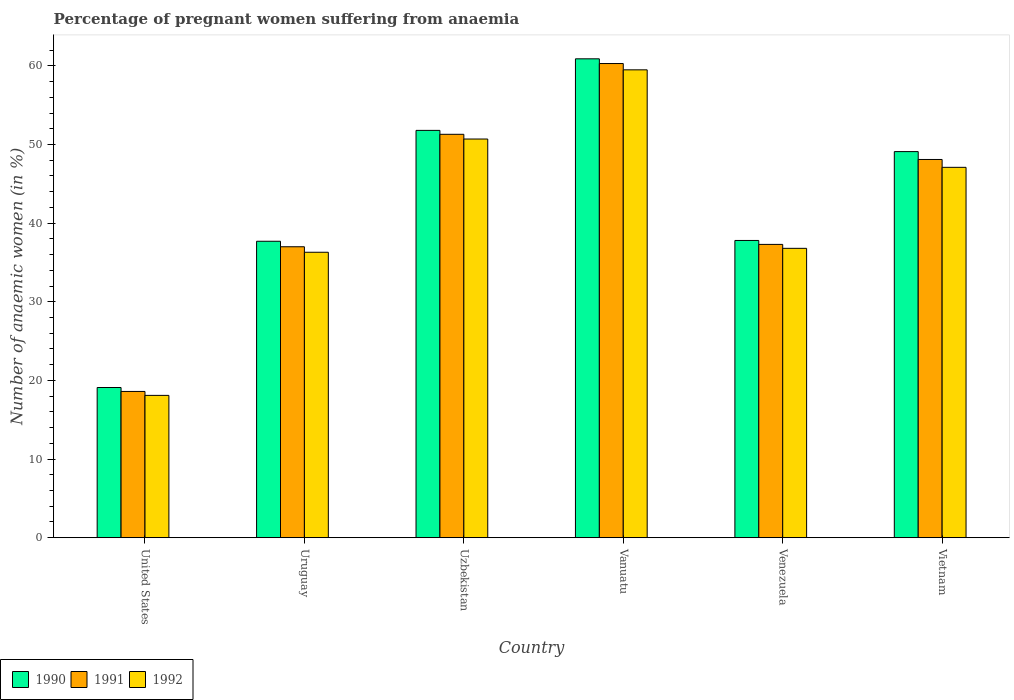How many bars are there on the 2nd tick from the right?
Provide a short and direct response. 3. What is the label of the 5th group of bars from the left?
Keep it short and to the point. Venezuela. What is the number of anaemic women in 1990 in Uzbekistan?
Offer a terse response. 51.8. Across all countries, what is the maximum number of anaemic women in 1990?
Provide a short and direct response. 60.9. Across all countries, what is the minimum number of anaemic women in 1991?
Give a very brief answer. 18.6. In which country was the number of anaemic women in 1992 maximum?
Your answer should be compact. Vanuatu. In which country was the number of anaemic women in 1990 minimum?
Give a very brief answer. United States. What is the total number of anaemic women in 1990 in the graph?
Give a very brief answer. 256.4. What is the difference between the number of anaemic women in 1992 in Vanuatu and that in Vietnam?
Provide a short and direct response. 12.4. What is the difference between the number of anaemic women in 1991 in United States and the number of anaemic women in 1992 in Uzbekistan?
Your answer should be very brief. -32.1. What is the average number of anaemic women in 1991 per country?
Offer a very short reply. 42.1. What is the difference between the number of anaemic women of/in 1990 and number of anaemic women of/in 1992 in Vanuatu?
Give a very brief answer. 1.4. What is the ratio of the number of anaemic women in 1990 in Vanuatu to that in Vietnam?
Ensure brevity in your answer.  1.24. What is the difference between the highest and the second highest number of anaemic women in 1990?
Your answer should be very brief. -2.7. What is the difference between the highest and the lowest number of anaemic women in 1990?
Make the answer very short. 41.8. What does the 1st bar from the left in Uruguay represents?
Your answer should be compact. 1990. Are all the bars in the graph horizontal?
Your answer should be very brief. No. How many countries are there in the graph?
Provide a succinct answer. 6. Are the values on the major ticks of Y-axis written in scientific E-notation?
Your response must be concise. No. Does the graph contain grids?
Give a very brief answer. No. Where does the legend appear in the graph?
Your answer should be compact. Bottom left. How many legend labels are there?
Provide a short and direct response. 3. How are the legend labels stacked?
Your answer should be very brief. Horizontal. What is the title of the graph?
Your answer should be very brief. Percentage of pregnant women suffering from anaemia. What is the label or title of the Y-axis?
Your answer should be compact. Number of anaemic women (in %). What is the Number of anaemic women (in %) in 1990 in Uruguay?
Provide a succinct answer. 37.7. What is the Number of anaemic women (in %) in 1992 in Uruguay?
Provide a succinct answer. 36.3. What is the Number of anaemic women (in %) of 1990 in Uzbekistan?
Ensure brevity in your answer.  51.8. What is the Number of anaemic women (in %) of 1991 in Uzbekistan?
Your answer should be very brief. 51.3. What is the Number of anaemic women (in %) of 1992 in Uzbekistan?
Give a very brief answer. 50.7. What is the Number of anaemic women (in %) in 1990 in Vanuatu?
Give a very brief answer. 60.9. What is the Number of anaemic women (in %) of 1991 in Vanuatu?
Your answer should be compact. 60.3. What is the Number of anaemic women (in %) of 1992 in Vanuatu?
Ensure brevity in your answer.  59.5. What is the Number of anaemic women (in %) in 1990 in Venezuela?
Offer a very short reply. 37.8. What is the Number of anaemic women (in %) in 1991 in Venezuela?
Give a very brief answer. 37.3. What is the Number of anaemic women (in %) in 1992 in Venezuela?
Offer a very short reply. 36.8. What is the Number of anaemic women (in %) in 1990 in Vietnam?
Offer a very short reply. 49.1. What is the Number of anaemic women (in %) in 1991 in Vietnam?
Keep it short and to the point. 48.1. What is the Number of anaemic women (in %) in 1992 in Vietnam?
Your answer should be very brief. 47.1. Across all countries, what is the maximum Number of anaemic women (in %) of 1990?
Offer a terse response. 60.9. Across all countries, what is the maximum Number of anaemic women (in %) in 1991?
Offer a terse response. 60.3. Across all countries, what is the maximum Number of anaemic women (in %) in 1992?
Ensure brevity in your answer.  59.5. Across all countries, what is the minimum Number of anaemic women (in %) in 1990?
Offer a terse response. 19.1. Across all countries, what is the minimum Number of anaemic women (in %) of 1992?
Offer a very short reply. 18.1. What is the total Number of anaemic women (in %) in 1990 in the graph?
Offer a very short reply. 256.4. What is the total Number of anaemic women (in %) of 1991 in the graph?
Give a very brief answer. 252.6. What is the total Number of anaemic women (in %) in 1992 in the graph?
Provide a short and direct response. 248.5. What is the difference between the Number of anaemic women (in %) in 1990 in United States and that in Uruguay?
Offer a very short reply. -18.6. What is the difference between the Number of anaemic women (in %) in 1991 in United States and that in Uruguay?
Keep it short and to the point. -18.4. What is the difference between the Number of anaemic women (in %) of 1992 in United States and that in Uruguay?
Offer a terse response. -18.2. What is the difference between the Number of anaemic women (in %) of 1990 in United States and that in Uzbekistan?
Offer a terse response. -32.7. What is the difference between the Number of anaemic women (in %) of 1991 in United States and that in Uzbekistan?
Your response must be concise. -32.7. What is the difference between the Number of anaemic women (in %) of 1992 in United States and that in Uzbekistan?
Provide a succinct answer. -32.6. What is the difference between the Number of anaemic women (in %) in 1990 in United States and that in Vanuatu?
Make the answer very short. -41.8. What is the difference between the Number of anaemic women (in %) of 1991 in United States and that in Vanuatu?
Provide a short and direct response. -41.7. What is the difference between the Number of anaemic women (in %) of 1992 in United States and that in Vanuatu?
Give a very brief answer. -41.4. What is the difference between the Number of anaemic women (in %) in 1990 in United States and that in Venezuela?
Make the answer very short. -18.7. What is the difference between the Number of anaemic women (in %) of 1991 in United States and that in Venezuela?
Offer a terse response. -18.7. What is the difference between the Number of anaemic women (in %) in 1992 in United States and that in Venezuela?
Ensure brevity in your answer.  -18.7. What is the difference between the Number of anaemic women (in %) of 1990 in United States and that in Vietnam?
Your answer should be compact. -30. What is the difference between the Number of anaemic women (in %) of 1991 in United States and that in Vietnam?
Provide a succinct answer. -29.5. What is the difference between the Number of anaemic women (in %) of 1992 in United States and that in Vietnam?
Your response must be concise. -29. What is the difference between the Number of anaemic women (in %) of 1990 in Uruguay and that in Uzbekistan?
Give a very brief answer. -14.1. What is the difference between the Number of anaemic women (in %) in 1991 in Uruguay and that in Uzbekistan?
Your response must be concise. -14.3. What is the difference between the Number of anaemic women (in %) of 1992 in Uruguay and that in Uzbekistan?
Your response must be concise. -14.4. What is the difference between the Number of anaemic women (in %) in 1990 in Uruguay and that in Vanuatu?
Your answer should be compact. -23.2. What is the difference between the Number of anaemic women (in %) of 1991 in Uruguay and that in Vanuatu?
Offer a terse response. -23.3. What is the difference between the Number of anaemic women (in %) in 1992 in Uruguay and that in Vanuatu?
Provide a succinct answer. -23.2. What is the difference between the Number of anaemic women (in %) of 1991 in Uruguay and that in Venezuela?
Make the answer very short. -0.3. What is the difference between the Number of anaemic women (in %) in 1991 in Uruguay and that in Vietnam?
Make the answer very short. -11.1. What is the difference between the Number of anaemic women (in %) of 1991 in Uzbekistan and that in Vanuatu?
Provide a succinct answer. -9. What is the difference between the Number of anaemic women (in %) of 1991 in Uzbekistan and that in Venezuela?
Give a very brief answer. 14. What is the difference between the Number of anaemic women (in %) in 1992 in Uzbekistan and that in Venezuela?
Make the answer very short. 13.9. What is the difference between the Number of anaemic women (in %) in 1990 in Uzbekistan and that in Vietnam?
Offer a terse response. 2.7. What is the difference between the Number of anaemic women (in %) of 1991 in Uzbekistan and that in Vietnam?
Make the answer very short. 3.2. What is the difference between the Number of anaemic women (in %) in 1992 in Uzbekistan and that in Vietnam?
Your answer should be compact. 3.6. What is the difference between the Number of anaemic women (in %) in 1990 in Vanuatu and that in Venezuela?
Make the answer very short. 23.1. What is the difference between the Number of anaemic women (in %) of 1991 in Vanuatu and that in Venezuela?
Offer a very short reply. 23. What is the difference between the Number of anaemic women (in %) of 1992 in Vanuatu and that in Venezuela?
Keep it short and to the point. 22.7. What is the difference between the Number of anaemic women (in %) of 1990 in Venezuela and that in Vietnam?
Offer a terse response. -11.3. What is the difference between the Number of anaemic women (in %) in 1990 in United States and the Number of anaemic women (in %) in 1991 in Uruguay?
Offer a terse response. -17.9. What is the difference between the Number of anaemic women (in %) in 1990 in United States and the Number of anaemic women (in %) in 1992 in Uruguay?
Provide a short and direct response. -17.2. What is the difference between the Number of anaemic women (in %) of 1991 in United States and the Number of anaemic women (in %) of 1992 in Uruguay?
Offer a terse response. -17.7. What is the difference between the Number of anaemic women (in %) of 1990 in United States and the Number of anaemic women (in %) of 1991 in Uzbekistan?
Your answer should be compact. -32.2. What is the difference between the Number of anaemic women (in %) of 1990 in United States and the Number of anaemic women (in %) of 1992 in Uzbekistan?
Offer a terse response. -31.6. What is the difference between the Number of anaemic women (in %) of 1991 in United States and the Number of anaemic women (in %) of 1992 in Uzbekistan?
Ensure brevity in your answer.  -32.1. What is the difference between the Number of anaemic women (in %) of 1990 in United States and the Number of anaemic women (in %) of 1991 in Vanuatu?
Make the answer very short. -41.2. What is the difference between the Number of anaemic women (in %) of 1990 in United States and the Number of anaemic women (in %) of 1992 in Vanuatu?
Your answer should be compact. -40.4. What is the difference between the Number of anaemic women (in %) of 1991 in United States and the Number of anaemic women (in %) of 1992 in Vanuatu?
Your answer should be compact. -40.9. What is the difference between the Number of anaemic women (in %) of 1990 in United States and the Number of anaemic women (in %) of 1991 in Venezuela?
Give a very brief answer. -18.2. What is the difference between the Number of anaemic women (in %) in 1990 in United States and the Number of anaemic women (in %) in 1992 in Venezuela?
Give a very brief answer. -17.7. What is the difference between the Number of anaemic women (in %) in 1991 in United States and the Number of anaemic women (in %) in 1992 in Venezuela?
Provide a short and direct response. -18.2. What is the difference between the Number of anaemic women (in %) in 1990 in United States and the Number of anaemic women (in %) in 1991 in Vietnam?
Keep it short and to the point. -29. What is the difference between the Number of anaemic women (in %) of 1990 in United States and the Number of anaemic women (in %) of 1992 in Vietnam?
Keep it short and to the point. -28. What is the difference between the Number of anaemic women (in %) in 1991 in United States and the Number of anaemic women (in %) in 1992 in Vietnam?
Your answer should be very brief. -28.5. What is the difference between the Number of anaemic women (in %) in 1990 in Uruguay and the Number of anaemic women (in %) in 1992 in Uzbekistan?
Offer a very short reply. -13. What is the difference between the Number of anaemic women (in %) in 1991 in Uruguay and the Number of anaemic women (in %) in 1992 in Uzbekistan?
Offer a very short reply. -13.7. What is the difference between the Number of anaemic women (in %) of 1990 in Uruguay and the Number of anaemic women (in %) of 1991 in Vanuatu?
Your response must be concise. -22.6. What is the difference between the Number of anaemic women (in %) in 1990 in Uruguay and the Number of anaemic women (in %) in 1992 in Vanuatu?
Give a very brief answer. -21.8. What is the difference between the Number of anaemic women (in %) of 1991 in Uruguay and the Number of anaemic women (in %) of 1992 in Vanuatu?
Provide a short and direct response. -22.5. What is the difference between the Number of anaemic women (in %) in 1990 in Uruguay and the Number of anaemic women (in %) in 1991 in Venezuela?
Provide a short and direct response. 0.4. What is the difference between the Number of anaemic women (in %) in 1990 in Uzbekistan and the Number of anaemic women (in %) in 1992 in Vanuatu?
Give a very brief answer. -7.7. What is the difference between the Number of anaemic women (in %) of 1990 in Uzbekistan and the Number of anaemic women (in %) of 1992 in Venezuela?
Ensure brevity in your answer.  15. What is the difference between the Number of anaemic women (in %) in 1991 in Uzbekistan and the Number of anaemic women (in %) in 1992 in Venezuela?
Provide a short and direct response. 14.5. What is the difference between the Number of anaemic women (in %) of 1990 in Uzbekistan and the Number of anaemic women (in %) of 1991 in Vietnam?
Make the answer very short. 3.7. What is the difference between the Number of anaemic women (in %) in 1990 in Uzbekistan and the Number of anaemic women (in %) in 1992 in Vietnam?
Your answer should be compact. 4.7. What is the difference between the Number of anaemic women (in %) in 1991 in Uzbekistan and the Number of anaemic women (in %) in 1992 in Vietnam?
Make the answer very short. 4.2. What is the difference between the Number of anaemic women (in %) in 1990 in Vanuatu and the Number of anaemic women (in %) in 1991 in Venezuela?
Provide a short and direct response. 23.6. What is the difference between the Number of anaemic women (in %) in 1990 in Vanuatu and the Number of anaemic women (in %) in 1992 in Venezuela?
Offer a very short reply. 24.1. What is the difference between the Number of anaemic women (in %) of 1991 in Vanuatu and the Number of anaemic women (in %) of 1992 in Vietnam?
Your answer should be very brief. 13.2. What is the difference between the Number of anaemic women (in %) in 1990 in Venezuela and the Number of anaemic women (in %) in 1991 in Vietnam?
Make the answer very short. -10.3. What is the difference between the Number of anaemic women (in %) of 1990 in Venezuela and the Number of anaemic women (in %) of 1992 in Vietnam?
Your answer should be very brief. -9.3. What is the difference between the Number of anaemic women (in %) in 1991 in Venezuela and the Number of anaemic women (in %) in 1992 in Vietnam?
Your answer should be very brief. -9.8. What is the average Number of anaemic women (in %) in 1990 per country?
Your answer should be very brief. 42.73. What is the average Number of anaemic women (in %) of 1991 per country?
Keep it short and to the point. 42.1. What is the average Number of anaemic women (in %) of 1992 per country?
Give a very brief answer. 41.42. What is the difference between the Number of anaemic women (in %) in 1991 and Number of anaemic women (in %) in 1992 in United States?
Your answer should be compact. 0.5. What is the difference between the Number of anaemic women (in %) of 1990 and Number of anaemic women (in %) of 1992 in Uruguay?
Your answer should be very brief. 1.4. What is the difference between the Number of anaemic women (in %) in 1990 and Number of anaemic women (in %) in 1992 in Uzbekistan?
Provide a succinct answer. 1.1. What is the difference between the Number of anaemic women (in %) of 1990 and Number of anaemic women (in %) of 1991 in Vanuatu?
Your response must be concise. 0.6. What is the difference between the Number of anaemic women (in %) in 1991 and Number of anaemic women (in %) in 1992 in Vanuatu?
Offer a terse response. 0.8. What is the difference between the Number of anaemic women (in %) of 1990 and Number of anaemic women (in %) of 1992 in Venezuela?
Your answer should be compact. 1. What is the difference between the Number of anaemic women (in %) in 1991 and Number of anaemic women (in %) in 1992 in Venezuela?
Offer a very short reply. 0.5. What is the difference between the Number of anaemic women (in %) of 1990 and Number of anaemic women (in %) of 1991 in Vietnam?
Offer a terse response. 1. What is the ratio of the Number of anaemic women (in %) in 1990 in United States to that in Uruguay?
Offer a very short reply. 0.51. What is the ratio of the Number of anaemic women (in %) of 1991 in United States to that in Uruguay?
Give a very brief answer. 0.5. What is the ratio of the Number of anaemic women (in %) of 1992 in United States to that in Uruguay?
Provide a succinct answer. 0.5. What is the ratio of the Number of anaemic women (in %) in 1990 in United States to that in Uzbekistan?
Offer a terse response. 0.37. What is the ratio of the Number of anaemic women (in %) in 1991 in United States to that in Uzbekistan?
Give a very brief answer. 0.36. What is the ratio of the Number of anaemic women (in %) of 1992 in United States to that in Uzbekistan?
Your response must be concise. 0.36. What is the ratio of the Number of anaemic women (in %) in 1990 in United States to that in Vanuatu?
Make the answer very short. 0.31. What is the ratio of the Number of anaemic women (in %) in 1991 in United States to that in Vanuatu?
Give a very brief answer. 0.31. What is the ratio of the Number of anaemic women (in %) of 1992 in United States to that in Vanuatu?
Ensure brevity in your answer.  0.3. What is the ratio of the Number of anaemic women (in %) in 1990 in United States to that in Venezuela?
Make the answer very short. 0.51. What is the ratio of the Number of anaemic women (in %) in 1991 in United States to that in Venezuela?
Provide a succinct answer. 0.5. What is the ratio of the Number of anaemic women (in %) of 1992 in United States to that in Venezuela?
Provide a short and direct response. 0.49. What is the ratio of the Number of anaemic women (in %) of 1990 in United States to that in Vietnam?
Your answer should be compact. 0.39. What is the ratio of the Number of anaemic women (in %) of 1991 in United States to that in Vietnam?
Offer a terse response. 0.39. What is the ratio of the Number of anaemic women (in %) of 1992 in United States to that in Vietnam?
Your answer should be very brief. 0.38. What is the ratio of the Number of anaemic women (in %) in 1990 in Uruguay to that in Uzbekistan?
Provide a succinct answer. 0.73. What is the ratio of the Number of anaemic women (in %) of 1991 in Uruguay to that in Uzbekistan?
Offer a terse response. 0.72. What is the ratio of the Number of anaemic women (in %) of 1992 in Uruguay to that in Uzbekistan?
Give a very brief answer. 0.72. What is the ratio of the Number of anaemic women (in %) of 1990 in Uruguay to that in Vanuatu?
Provide a short and direct response. 0.62. What is the ratio of the Number of anaemic women (in %) in 1991 in Uruguay to that in Vanuatu?
Your answer should be compact. 0.61. What is the ratio of the Number of anaemic women (in %) of 1992 in Uruguay to that in Vanuatu?
Give a very brief answer. 0.61. What is the ratio of the Number of anaemic women (in %) of 1990 in Uruguay to that in Venezuela?
Give a very brief answer. 1. What is the ratio of the Number of anaemic women (in %) in 1991 in Uruguay to that in Venezuela?
Provide a succinct answer. 0.99. What is the ratio of the Number of anaemic women (in %) in 1992 in Uruguay to that in Venezuela?
Your response must be concise. 0.99. What is the ratio of the Number of anaemic women (in %) in 1990 in Uruguay to that in Vietnam?
Your answer should be compact. 0.77. What is the ratio of the Number of anaemic women (in %) of 1991 in Uruguay to that in Vietnam?
Offer a terse response. 0.77. What is the ratio of the Number of anaemic women (in %) in 1992 in Uruguay to that in Vietnam?
Give a very brief answer. 0.77. What is the ratio of the Number of anaemic women (in %) in 1990 in Uzbekistan to that in Vanuatu?
Give a very brief answer. 0.85. What is the ratio of the Number of anaemic women (in %) of 1991 in Uzbekistan to that in Vanuatu?
Offer a terse response. 0.85. What is the ratio of the Number of anaemic women (in %) of 1992 in Uzbekistan to that in Vanuatu?
Keep it short and to the point. 0.85. What is the ratio of the Number of anaemic women (in %) in 1990 in Uzbekistan to that in Venezuela?
Your answer should be compact. 1.37. What is the ratio of the Number of anaemic women (in %) of 1991 in Uzbekistan to that in Venezuela?
Provide a short and direct response. 1.38. What is the ratio of the Number of anaemic women (in %) in 1992 in Uzbekistan to that in Venezuela?
Your answer should be very brief. 1.38. What is the ratio of the Number of anaemic women (in %) of 1990 in Uzbekistan to that in Vietnam?
Your answer should be very brief. 1.05. What is the ratio of the Number of anaemic women (in %) in 1991 in Uzbekistan to that in Vietnam?
Provide a short and direct response. 1.07. What is the ratio of the Number of anaemic women (in %) of 1992 in Uzbekistan to that in Vietnam?
Your response must be concise. 1.08. What is the ratio of the Number of anaemic women (in %) in 1990 in Vanuatu to that in Venezuela?
Give a very brief answer. 1.61. What is the ratio of the Number of anaemic women (in %) in 1991 in Vanuatu to that in Venezuela?
Your answer should be compact. 1.62. What is the ratio of the Number of anaemic women (in %) in 1992 in Vanuatu to that in Venezuela?
Ensure brevity in your answer.  1.62. What is the ratio of the Number of anaemic women (in %) in 1990 in Vanuatu to that in Vietnam?
Make the answer very short. 1.24. What is the ratio of the Number of anaemic women (in %) in 1991 in Vanuatu to that in Vietnam?
Ensure brevity in your answer.  1.25. What is the ratio of the Number of anaemic women (in %) of 1992 in Vanuatu to that in Vietnam?
Ensure brevity in your answer.  1.26. What is the ratio of the Number of anaemic women (in %) in 1990 in Venezuela to that in Vietnam?
Your answer should be very brief. 0.77. What is the ratio of the Number of anaemic women (in %) in 1991 in Venezuela to that in Vietnam?
Make the answer very short. 0.78. What is the ratio of the Number of anaemic women (in %) of 1992 in Venezuela to that in Vietnam?
Offer a very short reply. 0.78. What is the difference between the highest and the second highest Number of anaemic women (in %) of 1990?
Offer a very short reply. 9.1. What is the difference between the highest and the second highest Number of anaemic women (in %) of 1991?
Your response must be concise. 9. What is the difference between the highest and the second highest Number of anaemic women (in %) in 1992?
Offer a terse response. 8.8. What is the difference between the highest and the lowest Number of anaemic women (in %) of 1990?
Offer a very short reply. 41.8. What is the difference between the highest and the lowest Number of anaemic women (in %) in 1991?
Your response must be concise. 41.7. What is the difference between the highest and the lowest Number of anaemic women (in %) in 1992?
Provide a succinct answer. 41.4. 